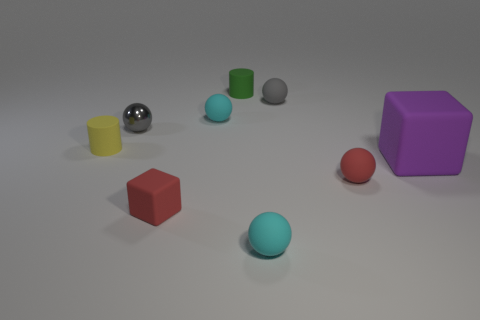Is there any other thing that has the same size as the purple rubber thing?
Offer a very short reply. No. Are there any small objects of the same color as the shiny sphere?
Make the answer very short. Yes. Do the yellow cylinder and the gray ball that is on the left side of the tiny green rubber cylinder have the same material?
Offer a very short reply. No. There is a cylinder behind the shiny sphere; is there a gray matte object that is in front of it?
Provide a succinct answer. Yes. There is a tiny matte ball that is left of the gray matte sphere and in front of the tiny metal sphere; what is its color?
Offer a very short reply. Cyan. The purple rubber object has what size?
Make the answer very short. Large. What number of yellow metallic cylinders have the same size as the metallic object?
Provide a succinct answer. 0. Is the large object that is in front of the small green matte cylinder made of the same material as the gray thing to the right of the green matte object?
Offer a very short reply. Yes. What material is the tiny gray ball in front of the tiny cyan thing behind the large purple object made of?
Give a very brief answer. Metal. There is a tiny yellow cylinder on the left side of the large purple rubber cube; what material is it?
Your answer should be compact. Rubber. 